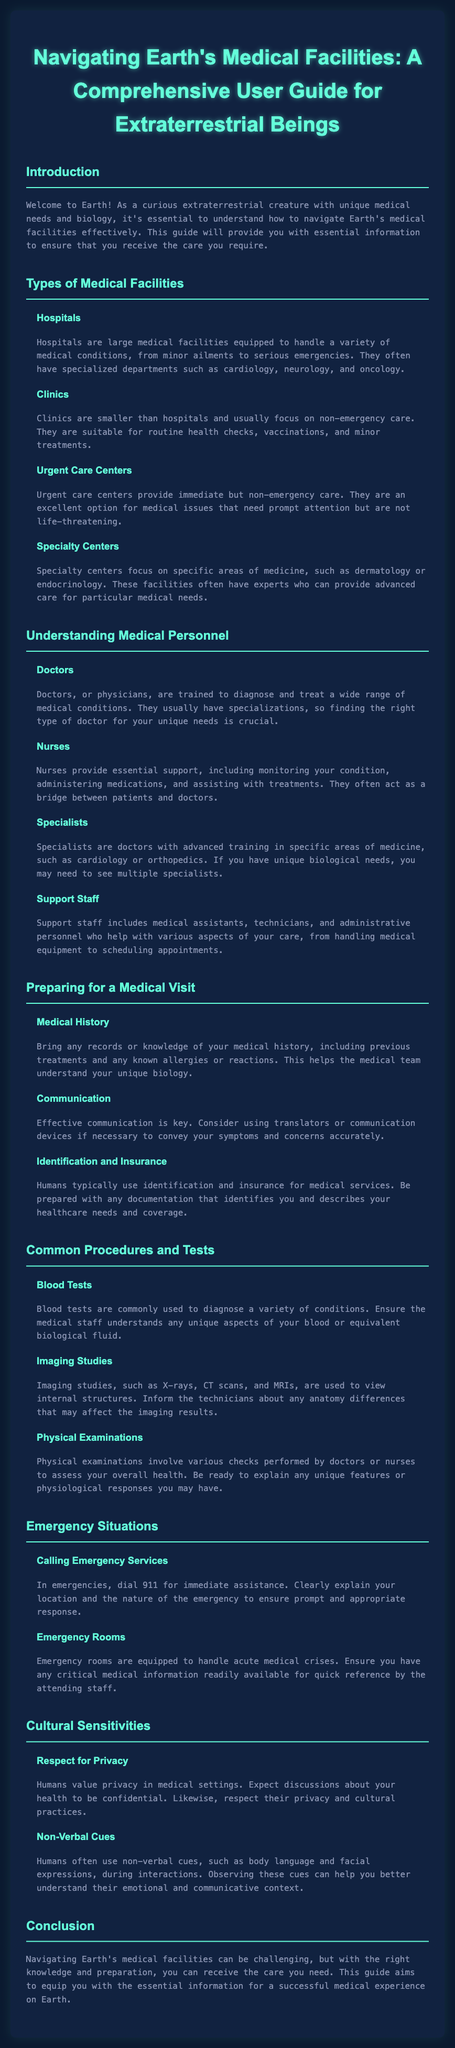what is the title of the document? The title is prominently displayed at the top of the document, indicating the subject matter.
Answer: Navigating Earth's Medical Facilities: A Comprehensive User Guide for Extraterrestrial Beings how many types of medical facilities are mentioned? The document lists various types of medical facilities under the relevant section, indicating their variety.
Answer: Four what is the primary purpose of hospitals? The document details the role of hospitals in addressing medical conditions, highlighting their capabilities.
Answer: Handle a variety of medical conditions who provides support during a medical visit? The guide explains the various roles of personnel in medical settings, including those who assist patients.
Answer: Nurses what number do you dial for emergency services? The document specifically mentions a number to call in emergencies, defining the action needed.
Answer: 911 what do you need to bring regarding your medical history? The guide emphasizes the importance of medical records for effective treatment and understanding.
Answer: Records or knowledge of your medical history what should you expect concerning privacy in medical settings? The document specifies cultural practices underlying interactions and procedural norms in medical contexts.
Answer: Confidential discussions what are the typical uses for blood tests? The text outlines the common applications of specific medical tests, providing a rationale for their use.
Answer: Diagnose a variety of conditions 